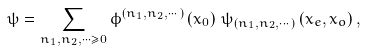Convert formula to latex. <formula><loc_0><loc_0><loc_500><loc_500>\psi = \sum _ { n _ { 1 } , n _ { 2 } , \cdots \geq 0 } \phi ^ { \left ( n _ { 1 } , n _ { 2 } , \cdots \right ) } \left ( x _ { 0 } \right ) \, \psi _ { \left ( n _ { 1 } , n _ { 2 } , \cdots \right ) } \left ( x _ { e } , x _ { o } \right ) ,</formula> 